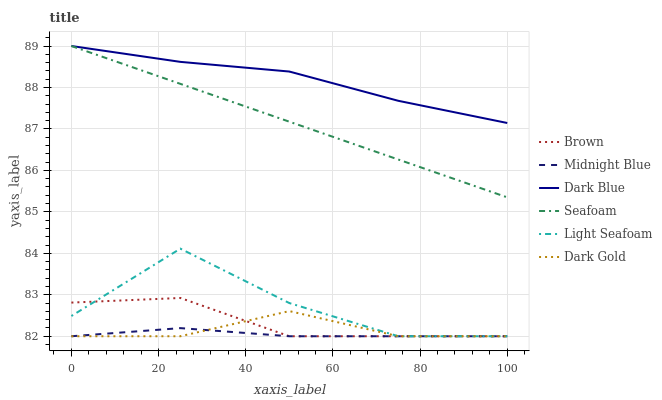Does Midnight Blue have the minimum area under the curve?
Answer yes or no. Yes. Does Dark Blue have the maximum area under the curve?
Answer yes or no. Yes. Does Dark Gold have the minimum area under the curve?
Answer yes or no. No. Does Dark Gold have the maximum area under the curve?
Answer yes or no. No. Is Seafoam the smoothest?
Answer yes or no. Yes. Is Light Seafoam the roughest?
Answer yes or no. Yes. Is Midnight Blue the smoothest?
Answer yes or no. No. Is Midnight Blue the roughest?
Answer yes or no. No. Does Brown have the lowest value?
Answer yes or no. Yes. Does Seafoam have the lowest value?
Answer yes or no. No. Does Dark Blue have the highest value?
Answer yes or no. Yes. Does Dark Gold have the highest value?
Answer yes or no. No. Is Midnight Blue less than Seafoam?
Answer yes or no. Yes. Is Seafoam greater than Dark Gold?
Answer yes or no. Yes. Does Light Seafoam intersect Dark Gold?
Answer yes or no. Yes. Is Light Seafoam less than Dark Gold?
Answer yes or no. No. Is Light Seafoam greater than Dark Gold?
Answer yes or no. No. Does Midnight Blue intersect Seafoam?
Answer yes or no. No. 